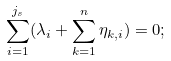Convert formula to latex. <formula><loc_0><loc_0><loc_500><loc_500>\sum _ { i = 1 } ^ { j _ { s } } ( \lambda _ { i } + \sum _ { k = 1 } ^ { n } \eta _ { k , i } ) = 0 ;</formula> 